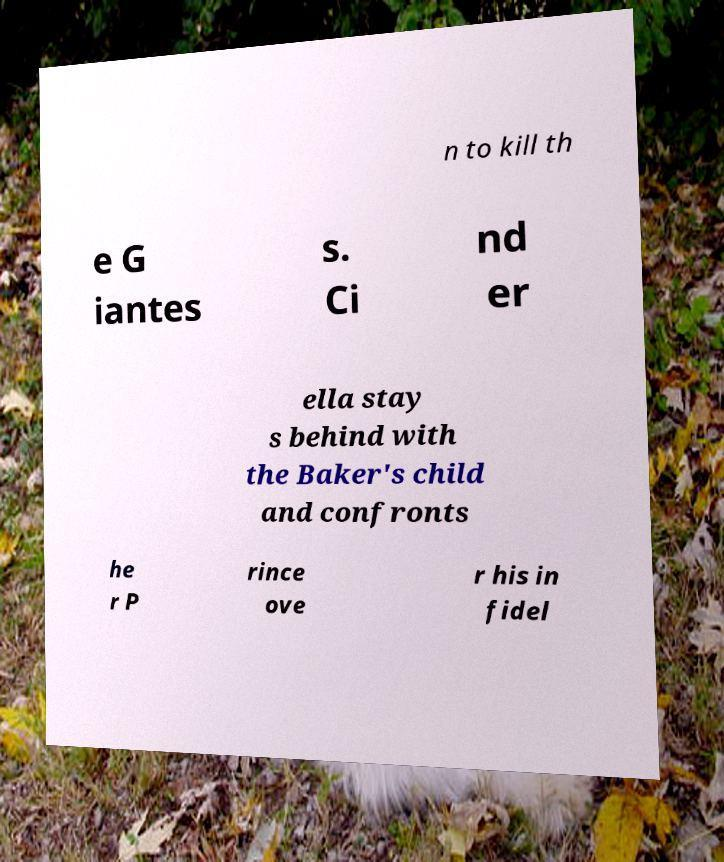Can you accurately transcribe the text from the provided image for me? n to kill th e G iantes s. Ci nd er ella stay s behind with the Baker's child and confronts he r P rince ove r his in fidel 